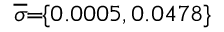Convert formula to latex. <formula><loc_0><loc_0><loc_500><loc_500>\, \overline { \sigma } \, = \, \{ 0 . 0 0 0 5 , 0 . 0 4 7 8 \} \,</formula> 